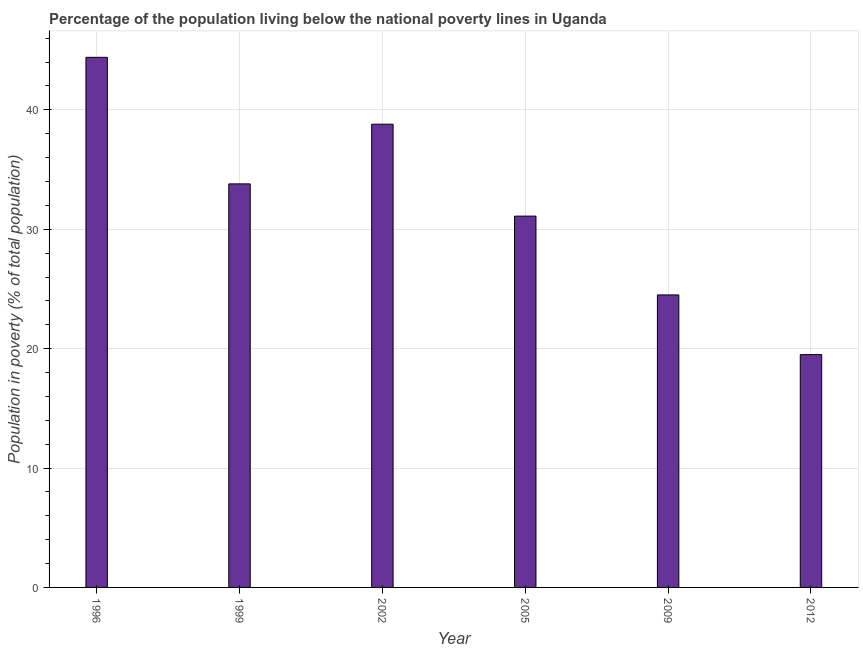Does the graph contain any zero values?
Make the answer very short. No. Does the graph contain grids?
Offer a terse response. Yes. What is the title of the graph?
Provide a short and direct response. Percentage of the population living below the national poverty lines in Uganda. What is the label or title of the Y-axis?
Provide a short and direct response. Population in poverty (% of total population). What is the percentage of population living below poverty line in 2002?
Ensure brevity in your answer.  38.8. Across all years, what is the maximum percentage of population living below poverty line?
Offer a very short reply. 44.4. Across all years, what is the minimum percentage of population living below poverty line?
Offer a very short reply. 19.5. What is the sum of the percentage of population living below poverty line?
Provide a short and direct response. 192.1. What is the average percentage of population living below poverty line per year?
Offer a very short reply. 32.02. What is the median percentage of population living below poverty line?
Offer a very short reply. 32.45. In how many years, is the percentage of population living below poverty line greater than 12 %?
Provide a short and direct response. 6. What is the ratio of the percentage of population living below poverty line in 1999 to that in 2005?
Your response must be concise. 1.09. What is the difference between the highest and the second highest percentage of population living below poverty line?
Your response must be concise. 5.6. Is the sum of the percentage of population living below poverty line in 1996 and 1999 greater than the maximum percentage of population living below poverty line across all years?
Offer a terse response. Yes. What is the difference between the highest and the lowest percentage of population living below poverty line?
Offer a very short reply. 24.9. How many bars are there?
Make the answer very short. 6. Are all the bars in the graph horizontal?
Offer a very short reply. No. Are the values on the major ticks of Y-axis written in scientific E-notation?
Provide a short and direct response. No. What is the Population in poverty (% of total population) in 1996?
Provide a succinct answer. 44.4. What is the Population in poverty (% of total population) in 1999?
Provide a succinct answer. 33.8. What is the Population in poverty (% of total population) of 2002?
Offer a very short reply. 38.8. What is the Population in poverty (% of total population) in 2005?
Offer a very short reply. 31.1. What is the Population in poverty (% of total population) of 2012?
Provide a succinct answer. 19.5. What is the difference between the Population in poverty (% of total population) in 1996 and 1999?
Your response must be concise. 10.6. What is the difference between the Population in poverty (% of total population) in 1996 and 2005?
Your answer should be compact. 13.3. What is the difference between the Population in poverty (% of total population) in 1996 and 2012?
Ensure brevity in your answer.  24.9. What is the difference between the Population in poverty (% of total population) in 1999 and 2002?
Make the answer very short. -5. What is the difference between the Population in poverty (% of total population) in 1999 and 2012?
Provide a succinct answer. 14.3. What is the difference between the Population in poverty (% of total population) in 2002 and 2005?
Provide a short and direct response. 7.7. What is the difference between the Population in poverty (% of total population) in 2002 and 2012?
Offer a very short reply. 19.3. What is the ratio of the Population in poverty (% of total population) in 1996 to that in 1999?
Your answer should be very brief. 1.31. What is the ratio of the Population in poverty (% of total population) in 1996 to that in 2002?
Offer a terse response. 1.14. What is the ratio of the Population in poverty (% of total population) in 1996 to that in 2005?
Your answer should be very brief. 1.43. What is the ratio of the Population in poverty (% of total population) in 1996 to that in 2009?
Keep it short and to the point. 1.81. What is the ratio of the Population in poverty (% of total population) in 1996 to that in 2012?
Make the answer very short. 2.28. What is the ratio of the Population in poverty (% of total population) in 1999 to that in 2002?
Make the answer very short. 0.87. What is the ratio of the Population in poverty (% of total population) in 1999 to that in 2005?
Offer a very short reply. 1.09. What is the ratio of the Population in poverty (% of total population) in 1999 to that in 2009?
Ensure brevity in your answer.  1.38. What is the ratio of the Population in poverty (% of total population) in 1999 to that in 2012?
Offer a terse response. 1.73. What is the ratio of the Population in poverty (% of total population) in 2002 to that in 2005?
Make the answer very short. 1.25. What is the ratio of the Population in poverty (% of total population) in 2002 to that in 2009?
Offer a terse response. 1.58. What is the ratio of the Population in poverty (% of total population) in 2002 to that in 2012?
Your response must be concise. 1.99. What is the ratio of the Population in poverty (% of total population) in 2005 to that in 2009?
Give a very brief answer. 1.27. What is the ratio of the Population in poverty (% of total population) in 2005 to that in 2012?
Provide a short and direct response. 1.59. What is the ratio of the Population in poverty (% of total population) in 2009 to that in 2012?
Provide a succinct answer. 1.26. 